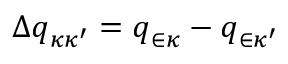Convert formula to latex. <formula><loc_0><loc_0><loc_500><loc_500>\Delta q _ { \kappa \kappa ^ { \prime } } = q _ { \in \kappa } - q _ { \in \kappa ^ { \prime } }</formula> 